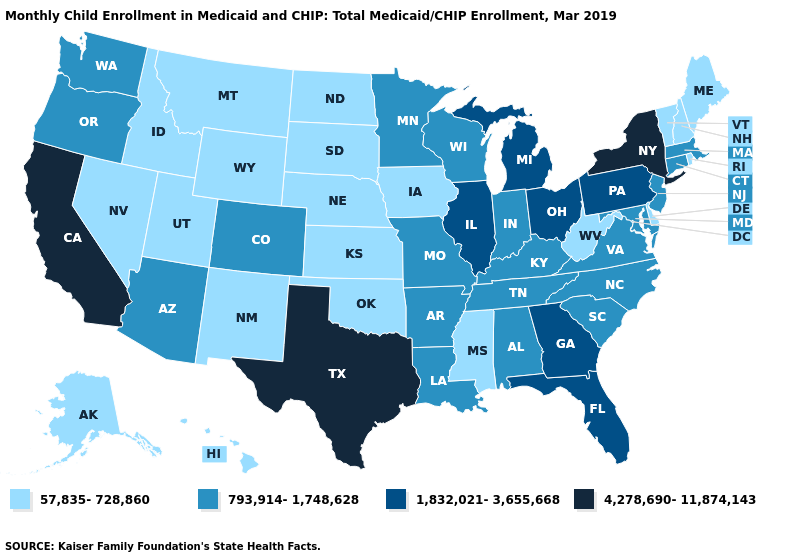Name the states that have a value in the range 57,835-728,860?
Short answer required. Alaska, Delaware, Hawaii, Idaho, Iowa, Kansas, Maine, Mississippi, Montana, Nebraska, Nevada, New Hampshire, New Mexico, North Dakota, Oklahoma, Rhode Island, South Dakota, Utah, Vermont, West Virginia, Wyoming. Which states have the highest value in the USA?
Be succinct. California, New York, Texas. Name the states that have a value in the range 1,832,021-3,655,668?
Concise answer only. Florida, Georgia, Illinois, Michigan, Ohio, Pennsylvania. Which states hav the highest value in the West?
Write a very short answer. California. What is the value of Louisiana?
Quick response, please. 793,914-1,748,628. What is the value of Oregon?
Be succinct. 793,914-1,748,628. Does Hawaii have the same value as South Dakota?
Concise answer only. Yes. Name the states that have a value in the range 1,832,021-3,655,668?
Keep it brief. Florida, Georgia, Illinois, Michigan, Ohio, Pennsylvania. Name the states that have a value in the range 4,278,690-11,874,143?
Be succinct. California, New York, Texas. What is the value of Mississippi?
Be succinct. 57,835-728,860. Which states have the lowest value in the South?
Answer briefly. Delaware, Mississippi, Oklahoma, West Virginia. Does New York have the highest value in the Northeast?
Concise answer only. Yes. Does Maine have the same value as North Dakota?
Concise answer only. Yes. Does Virginia have a higher value than Kansas?
Be succinct. Yes. What is the value of Virginia?
Concise answer only. 793,914-1,748,628. 